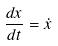<formula> <loc_0><loc_0><loc_500><loc_500>\frac { d x } { d t } = \dot { x }</formula> 